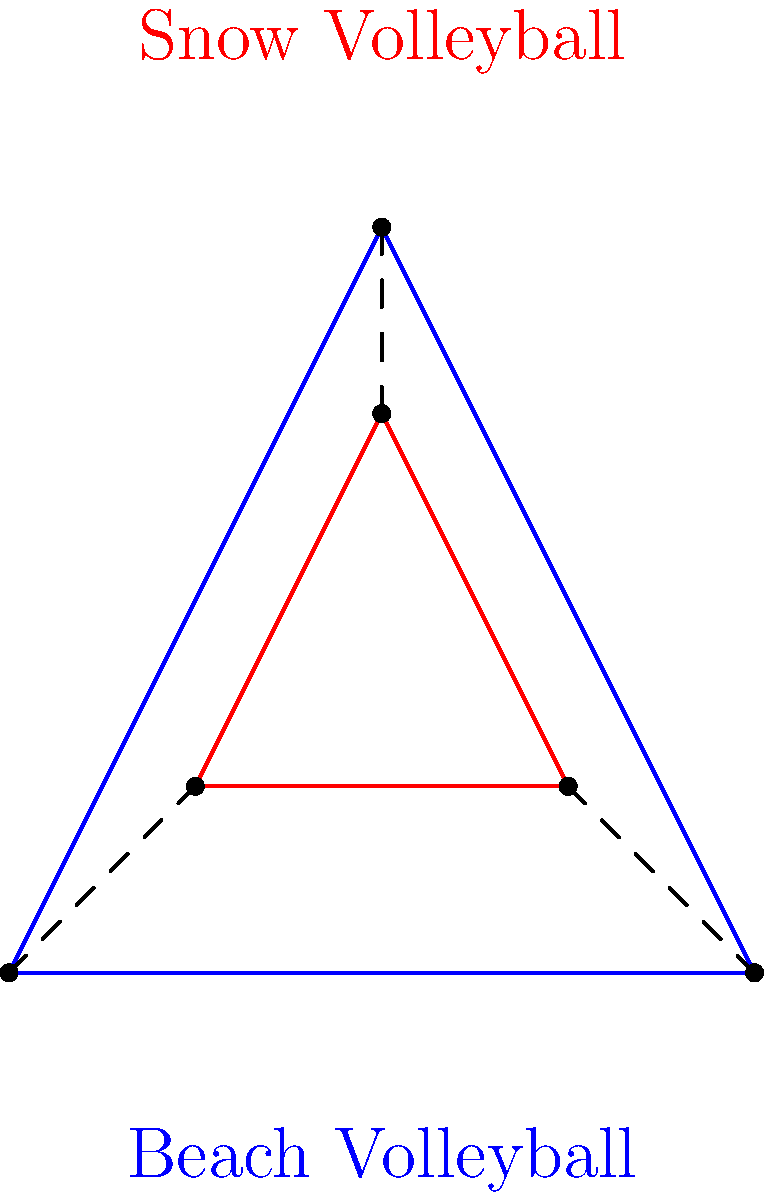Consider the continuous deformation of a beach volleyball (represented by the blue triangle) into a snow volleyball (represented by the red triangle). If this transformation is a homeomorphism, which of the following statements must be true?

1. The number of vertices remains the same
2. The area of the triangle changes
3. The length of the sides remains constant
4. The angles of the triangle are preserved Let's analyze this step-by-step:

1. A homeomorphism is a continuous function between topological spaces that has a continuous inverse function. It preserves topological properties.

2. In a homeomorphism:
   a) The number of vertices is preserved because it's a topological property. This is true.
   b) The area can change because metric properties are not necessarily preserved. This can be true.
   c) The length of sides can change because metric properties are not necessarily preserved. This can be true.
   d) Angles are not necessarily preserved in a homeomorphism. This can be false.

3. The key aspect of a homeomorphism is that it maintains the fundamental structure and connectivity of the object. It can stretch, bend, or twist the object, but it cannot tear or glue parts together.

4. In this transformation:
   - The triangular shape (3 vertices connected by 3 edges) is maintained.
   - The size and proportions can change (as seen in the diagram).
   - The specific angles and side lengths can change.

5. Therefore, the only statement that must be true for this transformation to be a homeomorphism is that the number of vertices remains the same.
Answer: The number of vertices remains the same 